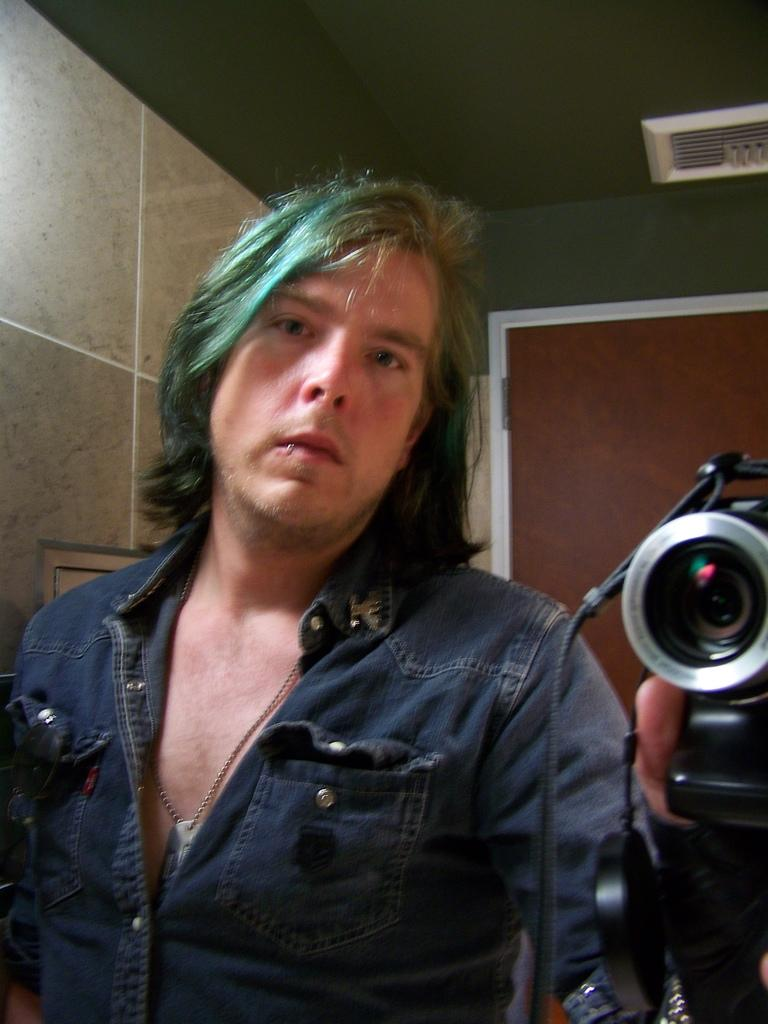What is the person in the image doing? The person is holding a camera and posing for a picture. What object is the person using to take the picture? The person is holding a camera. What can be seen in the background of the image? There is a mirror, a wall, and a door in the image. What time of day is it in the image? The time of day cannot be determined from the image, as there is no information about lighting or shadows. What type of lift present in the image? There is no lift present in the image. 